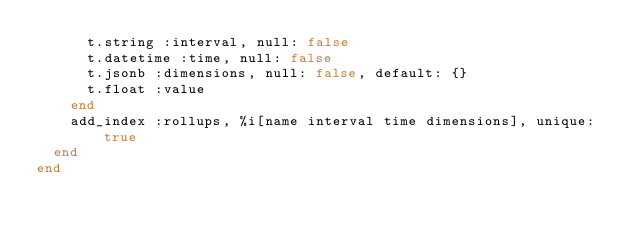<code> <loc_0><loc_0><loc_500><loc_500><_Ruby_>      t.string :interval, null: false
      t.datetime :time, null: false
      t.jsonb :dimensions, null: false, default: {}
      t.float :value
    end
    add_index :rollups, %i[name interval time dimensions], unique: true
  end
end
</code> 